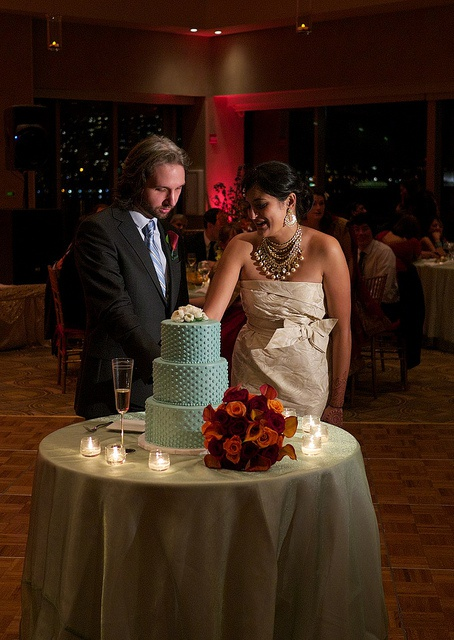Describe the objects in this image and their specific colors. I can see dining table in maroon, black, and gray tones, people in maroon, black, brown, and tan tones, people in maroon, black, brown, and gray tones, cake in maroon, gray, black, darkgreen, and darkgray tones, and people in maroon, black, and brown tones in this image. 